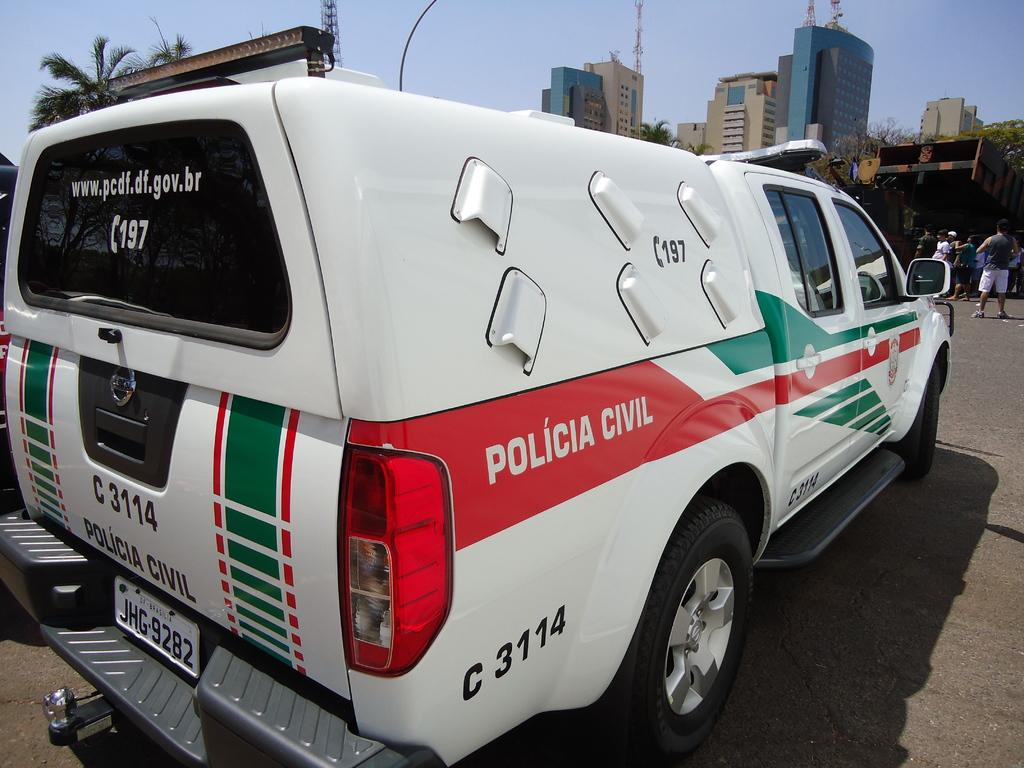<image>
Provide a brief description of the given image. A Brazilian police vehicle that is white, red and green. 